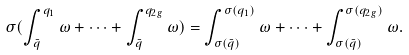<formula> <loc_0><loc_0><loc_500><loc_500>\sigma ( \int ^ { q _ { 1 } } _ { \bar { q } } \omega + \dots + \int ^ { q _ { 2 g } } _ { \bar { q } } \omega ) = \int ^ { \sigma ( q _ { 1 } ) } _ { \sigma ( \bar { q } ) } \omega + \dots + \int ^ { \sigma ( q _ { 2 g } ) } _ { \sigma ( \bar { q } ) } \omega .</formula> 